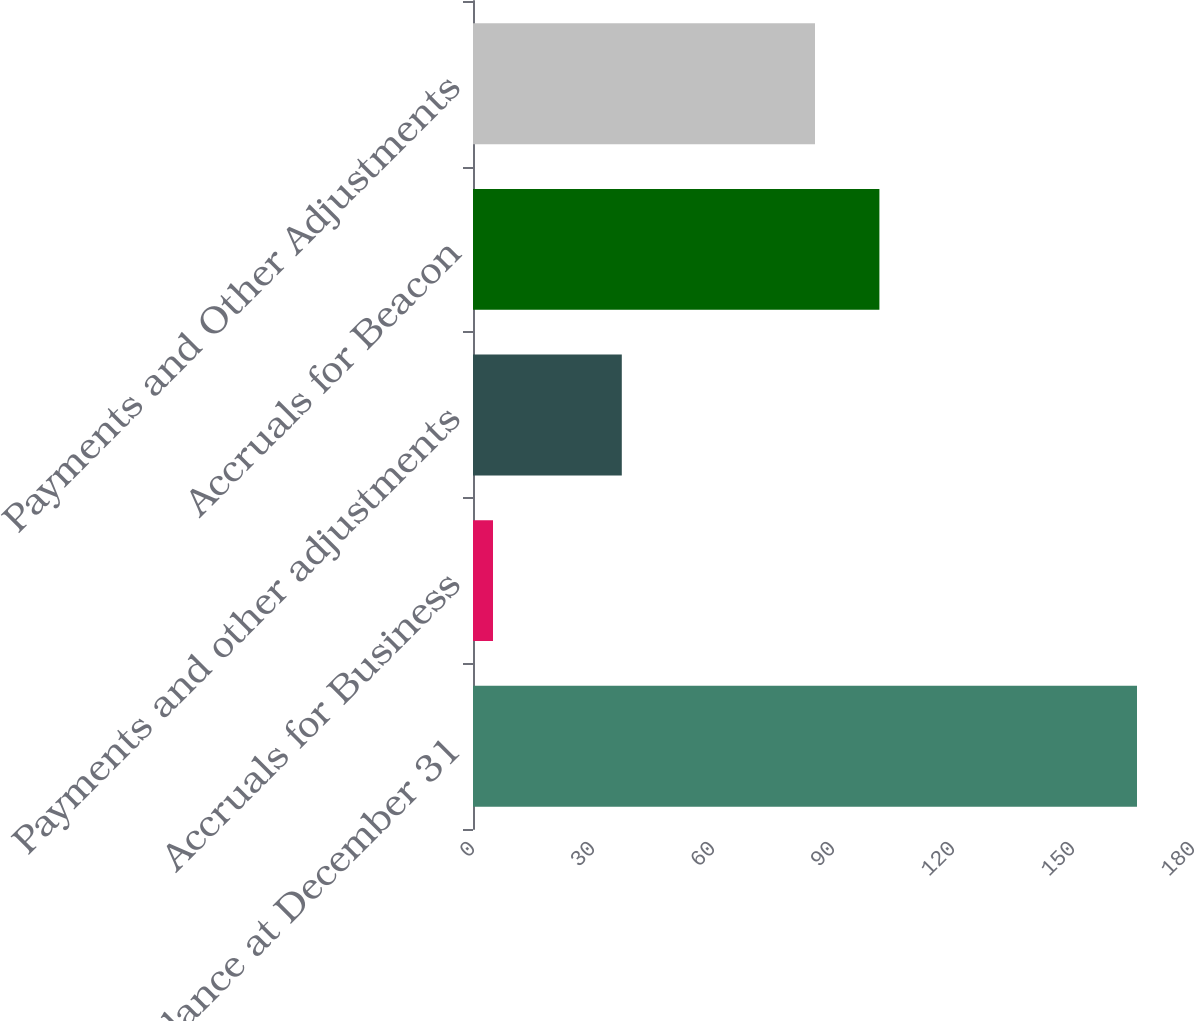Convert chart. <chart><loc_0><loc_0><loc_500><loc_500><bar_chart><fcel>Accrual Balance at December 31<fcel>Accruals for Business<fcel>Payments and other adjustments<fcel>Accruals for Beacon<fcel>Payments and Other Adjustments<nl><fcel>166<fcel>5<fcel>37.2<fcel>101.6<fcel>85.5<nl></chart> 